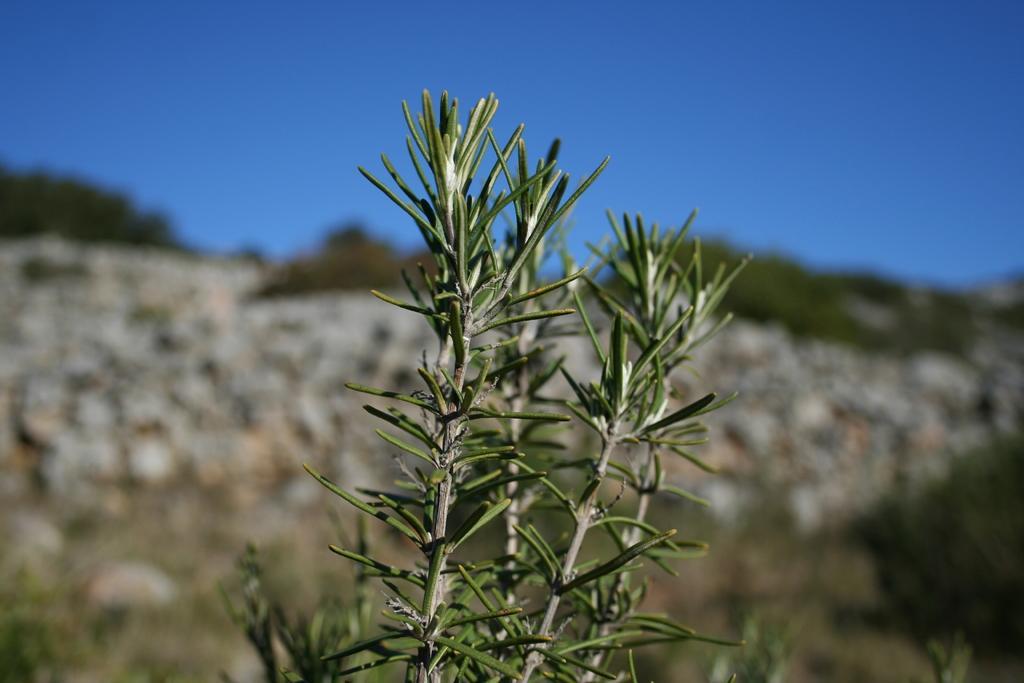Can you describe this image briefly? These are the green plants in the long back side it is a blue color sky. 